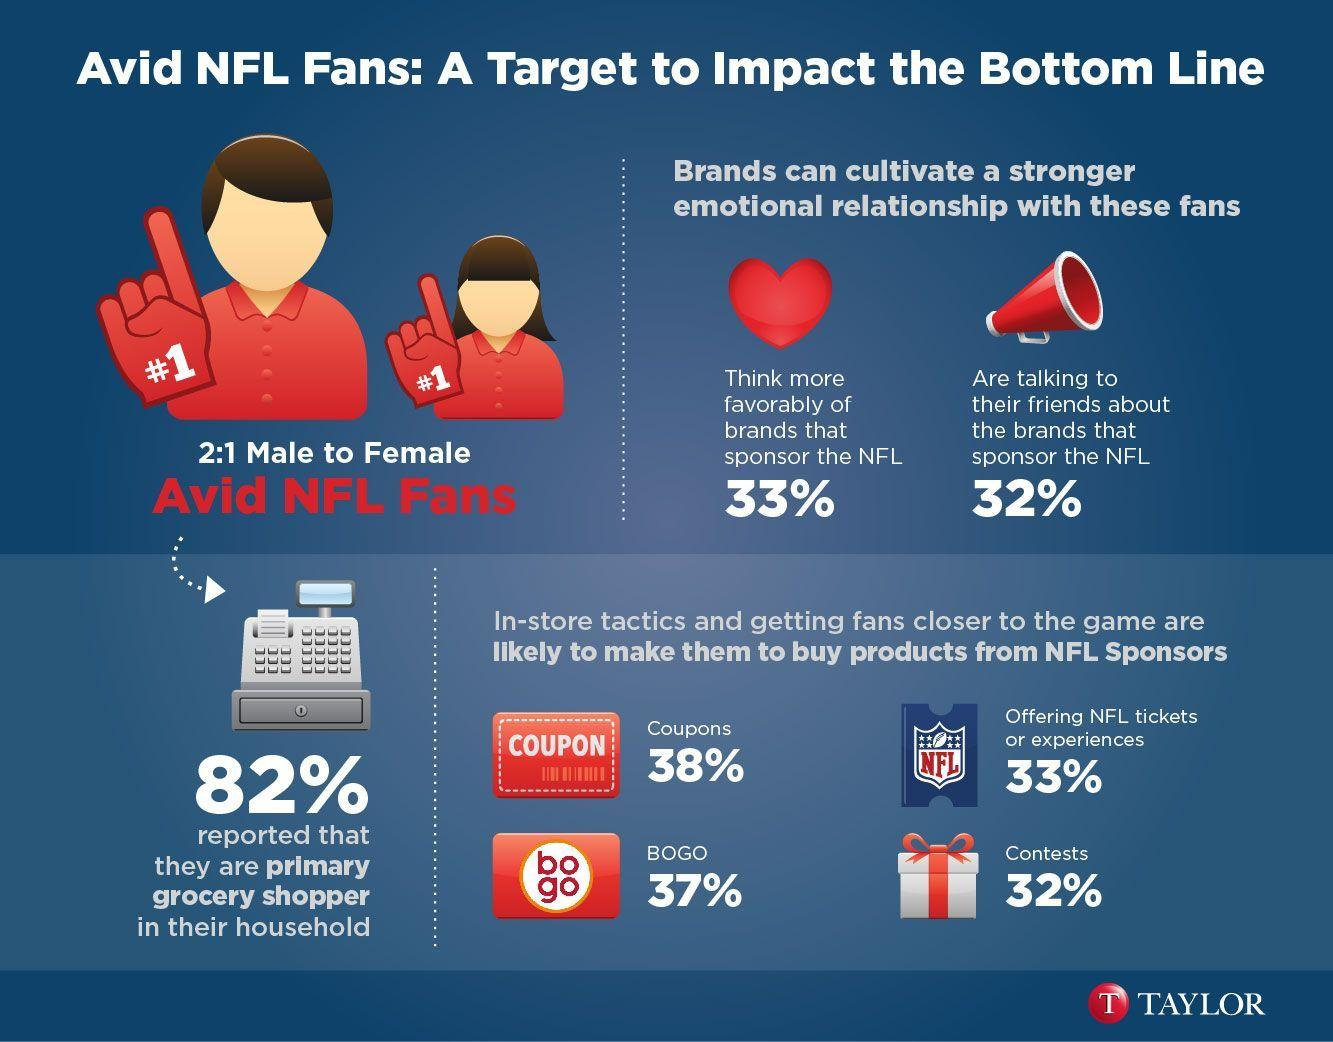Draw attention to some important aspects in this diagram. A significant proportion of stores, at 32%, use in-store tactics to encourage consumers to purchase products. One such tactic is contests, which have been shown to be effective in driving sales. According to a recent survey, 82% of stores use NFL coupons to attract consumers, 38% use them frequently, and 33% occasionally. 